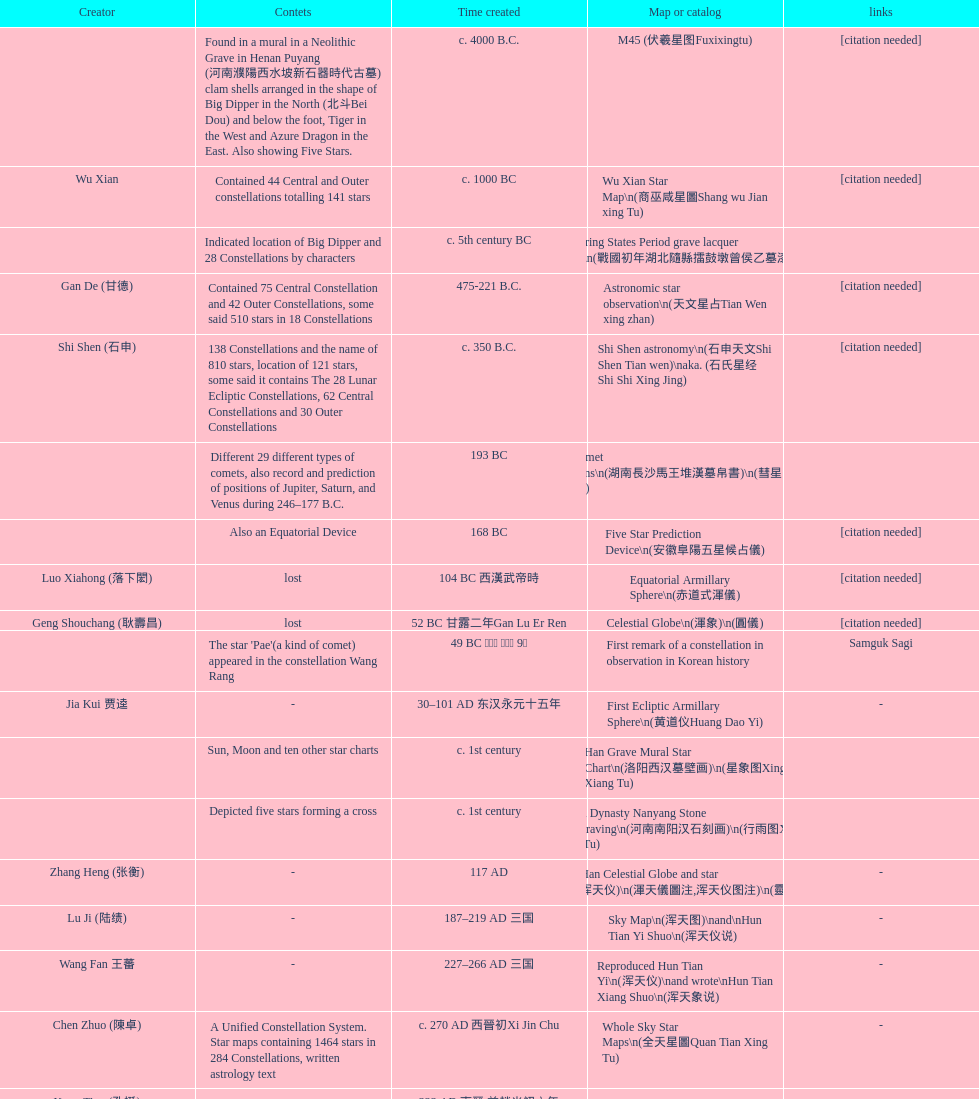What is the variation between the creation date of the five star prediction device and the creation date of the han comet diagrams? 25 years. 